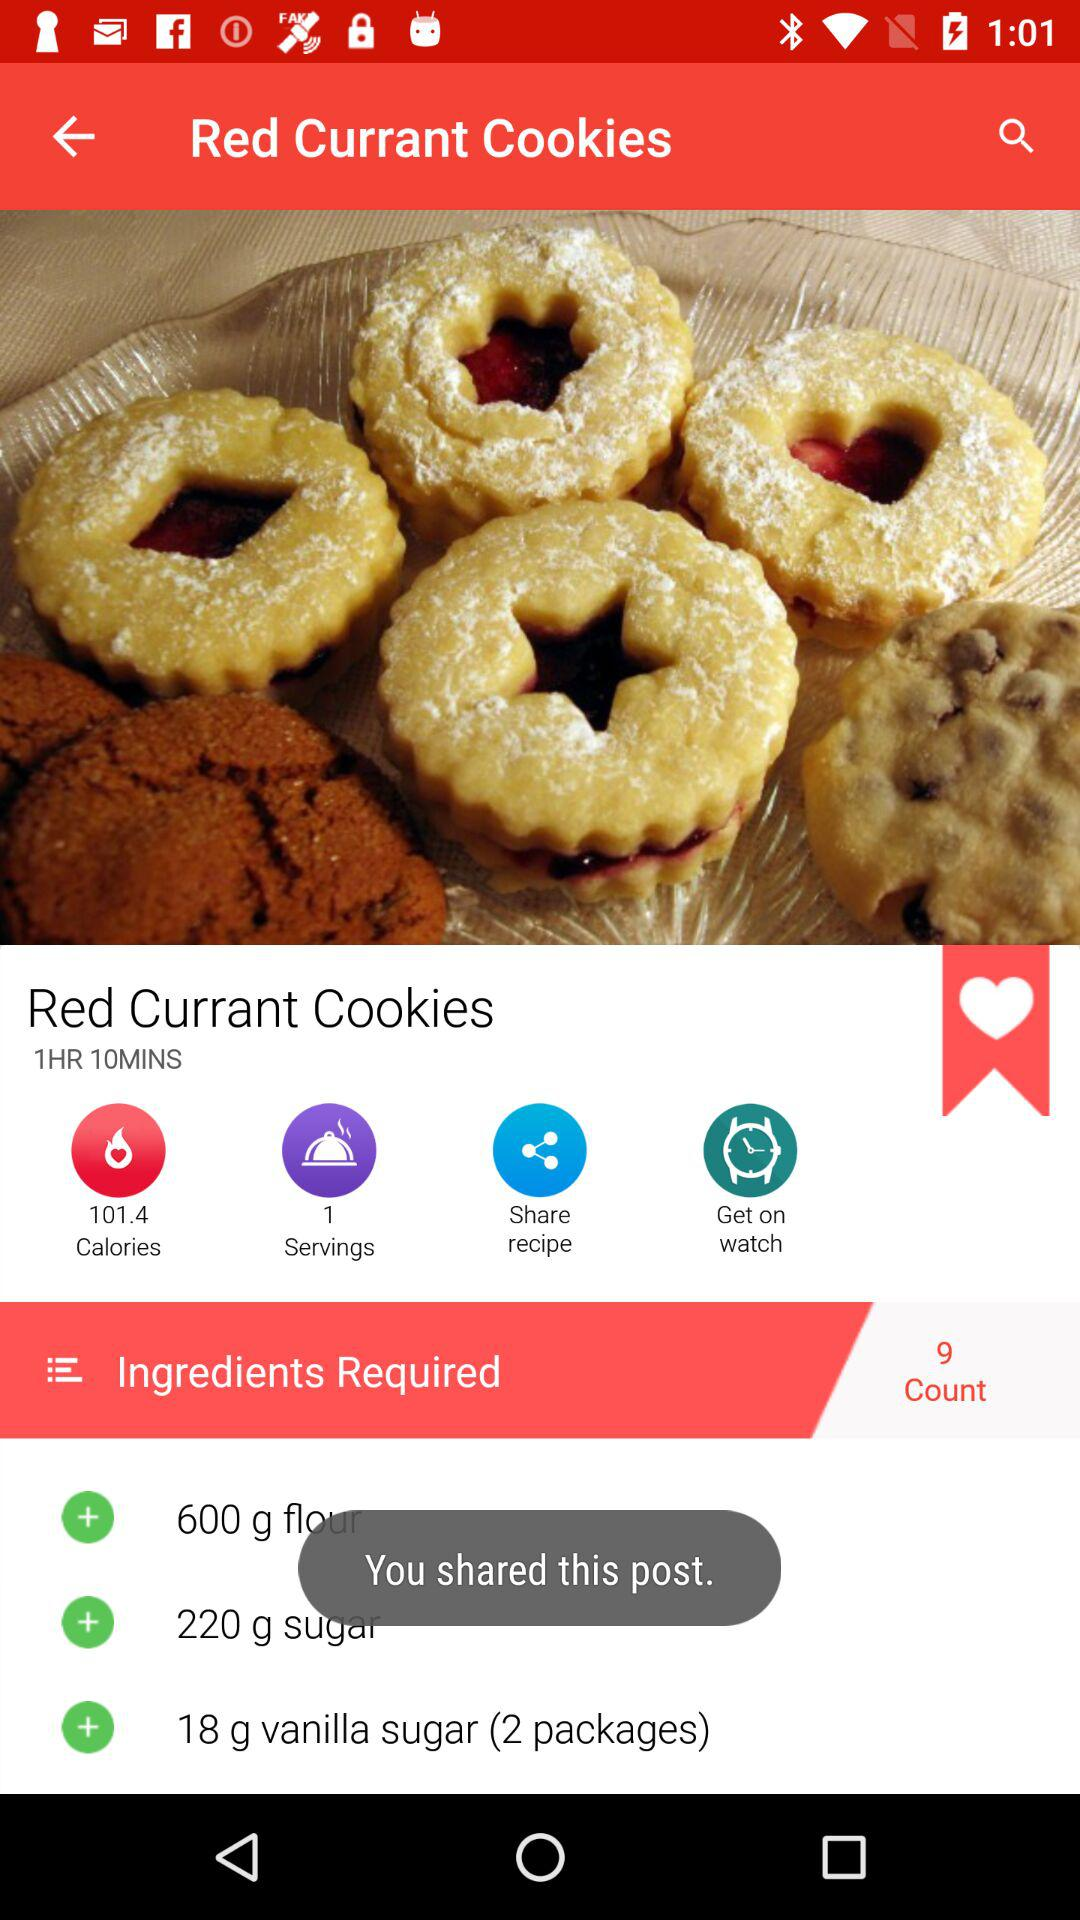How many calories are there in the "Red Currant Cookies"? There are 101.4 calories in the "Red Currant Cookies". 